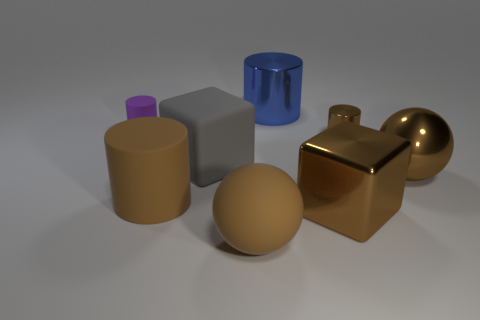Subtract all purple cylinders. How many cylinders are left? 3 Subtract all brown metallic cylinders. How many cylinders are left? 3 Subtract all green cylinders. Subtract all cyan blocks. How many cylinders are left? 4 Add 2 cylinders. How many objects exist? 10 Subtract all balls. How many objects are left? 6 Add 1 large spheres. How many large spheres are left? 3 Add 7 tiny purple matte things. How many tiny purple matte things exist? 8 Subtract 0 yellow cubes. How many objects are left? 8 Subtract all gray balls. Subtract all large brown rubber balls. How many objects are left? 7 